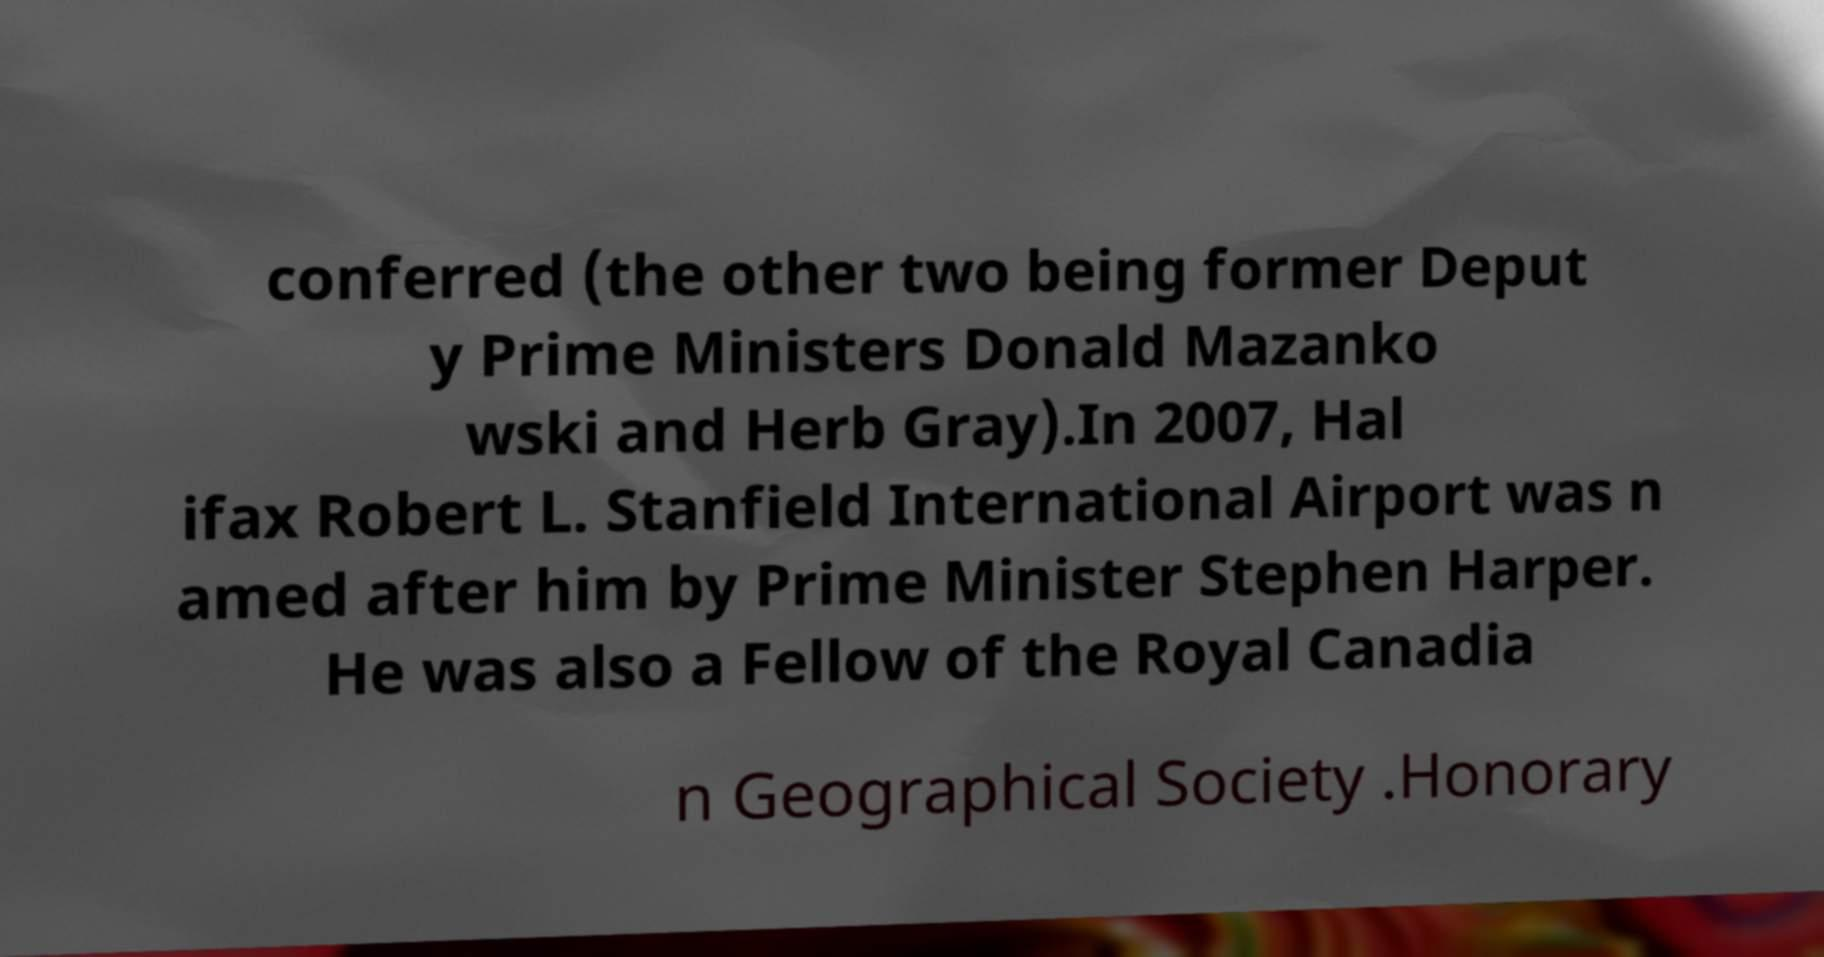Can you accurately transcribe the text from the provided image for me? conferred (the other two being former Deput y Prime Ministers Donald Mazanko wski and Herb Gray).In 2007, Hal ifax Robert L. Stanfield International Airport was n amed after him by Prime Minister Stephen Harper. He was also a Fellow of the Royal Canadia n Geographical Society .Honorary 